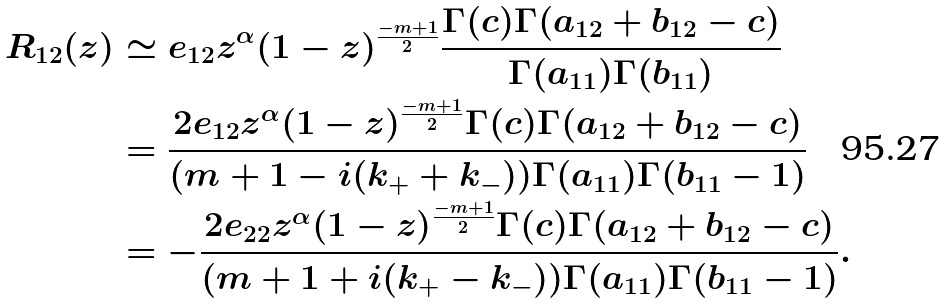<formula> <loc_0><loc_0><loc_500><loc_500>R _ { 1 2 } ( z ) & \simeq e _ { 1 2 } z ^ { \alpha } ( 1 - z ) ^ { \frac { - m + 1 } { 2 } } \frac { \Gamma ( c ) \Gamma ( a _ { 1 2 } + b _ { 1 2 } - c ) } { \Gamma ( a _ { 1 1 } ) \Gamma ( b _ { 1 1 } ) } \\ & = \frac { 2 e _ { 1 2 } z ^ { \alpha } ( 1 - z ) ^ { \frac { - m + 1 } { 2 } } \Gamma ( c ) \Gamma ( a _ { 1 2 } + b _ { 1 2 } - c ) } { ( m + 1 - i ( k _ { + } + k _ { - } ) ) \Gamma ( a _ { 1 1 } ) \Gamma ( b _ { 1 1 } - 1 ) } \\ & = - \frac { 2 e _ { 2 2 } z ^ { \alpha } ( 1 - z ) ^ { \frac { - m + 1 } { 2 } } \Gamma ( c ) \Gamma ( a _ { 1 2 } + b _ { 1 2 } - c ) } { ( m + 1 + i ( k _ { + } - k _ { - } ) ) \Gamma ( a _ { 1 1 } ) \Gamma ( b _ { 1 1 } - 1 ) } .</formula> 